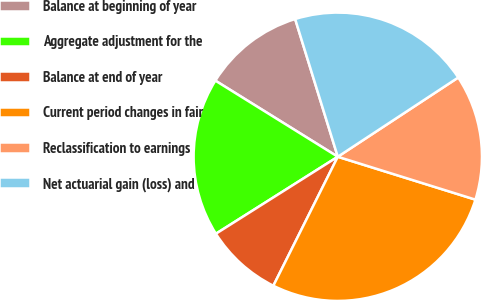Convert chart. <chart><loc_0><loc_0><loc_500><loc_500><pie_chart><fcel>Balance at beginning of year<fcel>Aggregate adjustment for the<fcel>Balance at end of year<fcel>Current period changes in fair<fcel>Reclassification to earnings<fcel>Net actuarial gain (loss) and<nl><fcel>11.37%<fcel>17.82%<fcel>8.66%<fcel>27.57%<fcel>14.07%<fcel>20.52%<nl></chart> 